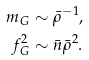<formula> <loc_0><loc_0><loc_500><loc_500>m _ { G } & \sim \bar { \rho } ^ { - 1 } , \\ f _ { G } ^ { 2 } & \sim \bar { n } \bar { \rho } ^ { 2 } .</formula> 